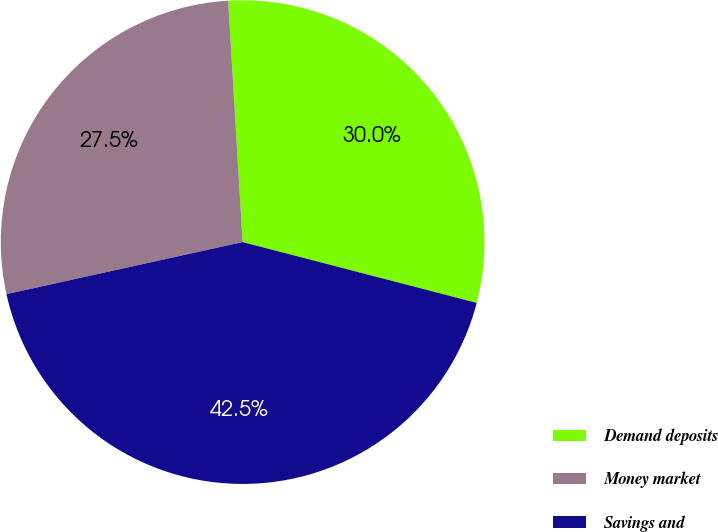<chart> <loc_0><loc_0><loc_500><loc_500><pie_chart><fcel>Demand deposits<fcel>Money market<fcel>Savings and<nl><fcel>30.0%<fcel>27.5%<fcel>42.5%<nl></chart> 